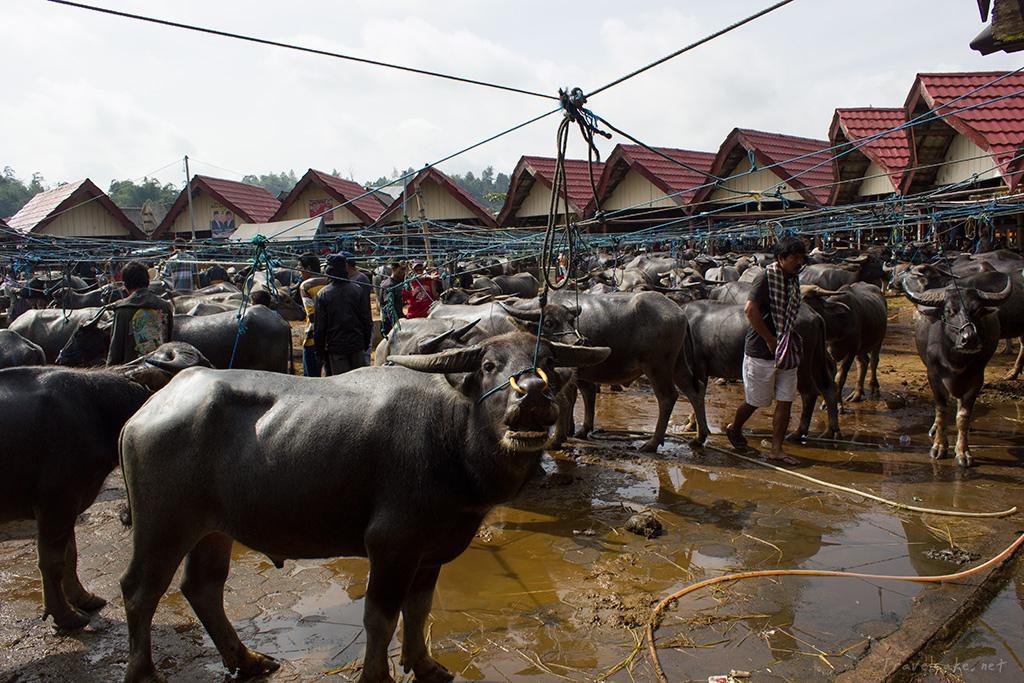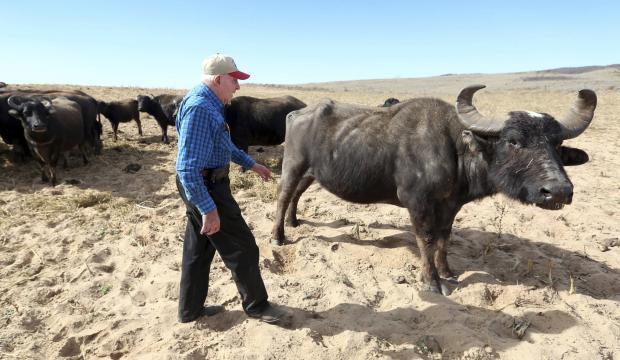The first image is the image on the left, the second image is the image on the right. Examine the images to the left and right. Is the description "One image includes a person standing by a water buffalo in a wet area, and the other image shows one person in blue standing by water buffalo on dry ground." accurate? Answer yes or no. Yes. The first image is the image on the left, the second image is the image on the right. Considering the images on both sides, is "In at least one image there is a single man with short hair to the left of a horned ox." valid? Answer yes or no. Yes. 